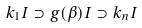Convert formula to latex. <formula><loc_0><loc_0><loc_500><loc_500>k _ { 1 } I \supset g ( \beta ) I \supset k _ { n } I</formula> 